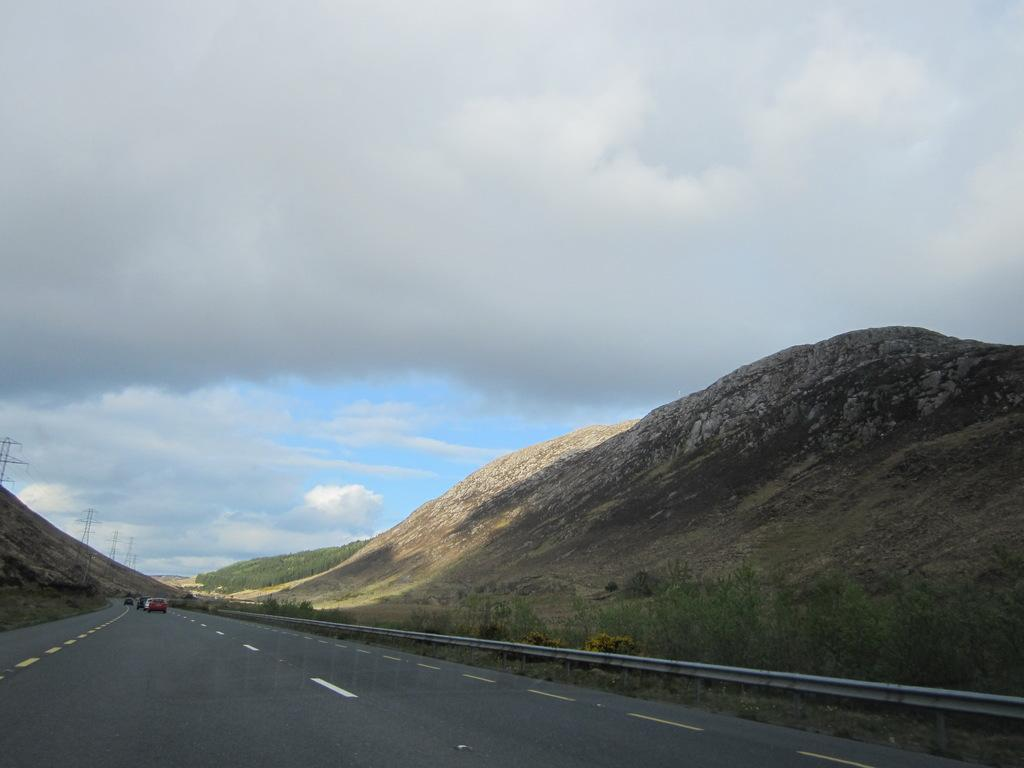What can be seen on the road in the image? There are vehicles on the road in the image. What type of barrier is present in the image? There is a fence in the image. What type of natural elements are visible in the image? There are plants and mountains in the image. What type of structures can be seen in the image? There are towers in the image. What is visible in the background of the image? The sky is visible in the background of the image. What atmospheric conditions can be observed in the sky? Clouds are present in the sky. How many rings are visible on the towers in the image? There are no rings visible on the towers in the image. What type of authority is depicted in the image? The image does not depict any specific authority or governing body. 